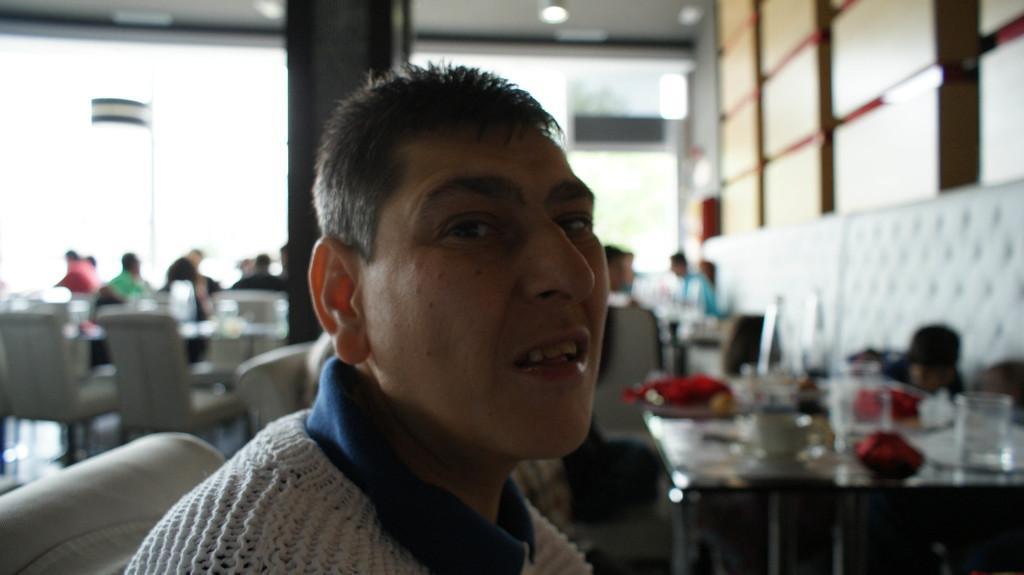Describe this image in one or two sentences. In this image, there is a person on the blur background. This person is wearing clothes and there is a table in the bottom right of the image. 